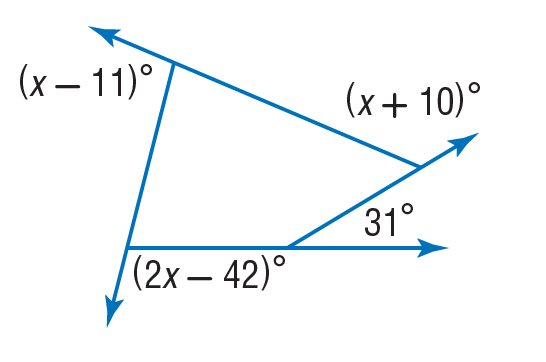Answer the mathemtical geometry problem and directly provide the correct option letter.
Question: Find the value of x in the diagram.
Choices: A: 10 B: 11 C: 31 D: 93 D 